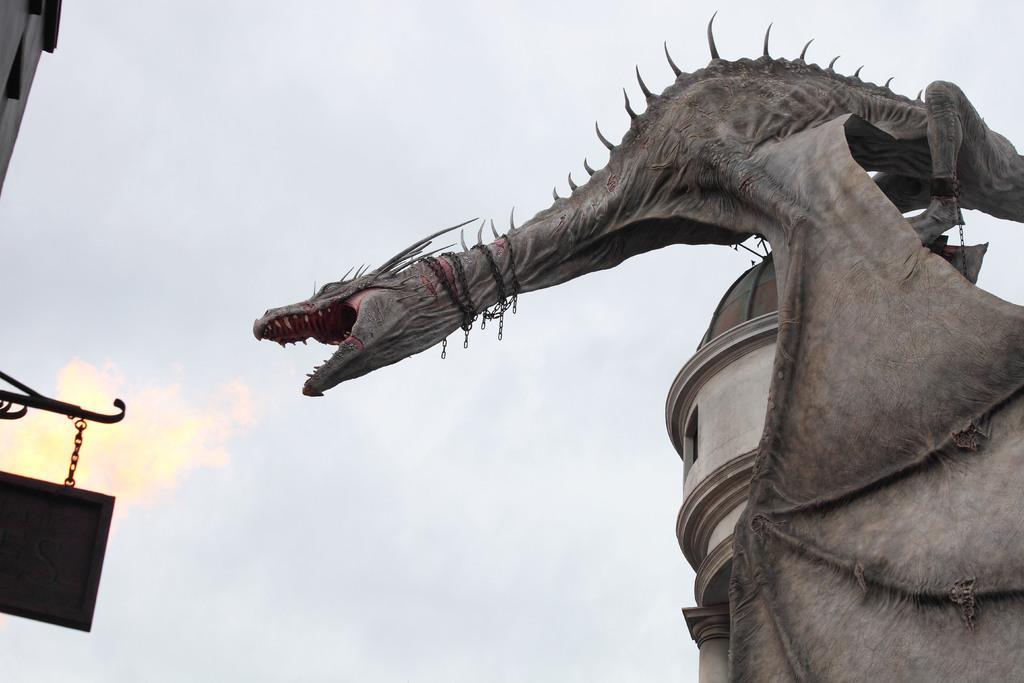How would you summarize this image in a sentence or two? In the image there is a giant sculpture of dragon and the dragon is sitting on the tower,in the background there is a sky. 